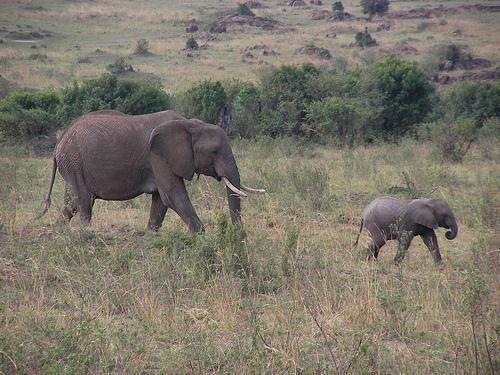How many elephants are there?
Give a very brief answer. 2. How many elephants have tusks?
Give a very brief answer. 1. 